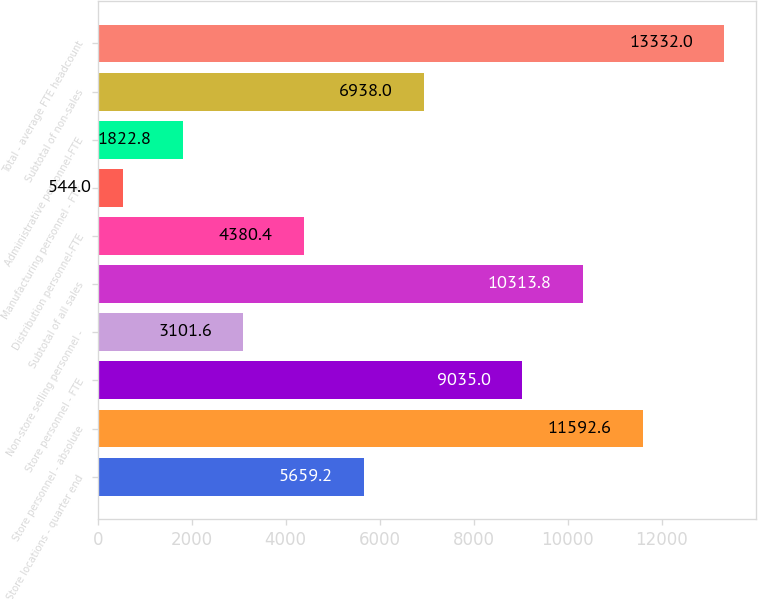<chart> <loc_0><loc_0><loc_500><loc_500><bar_chart><fcel>Store locations - quarter end<fcel>Store personnel - absolute<fcel>Store personnel - FTE<fcel>Non-store selling personnel -<fcel>Subtotal of all sales<fcel>Distribution personnel-FTE<fcel>Manufacturing personnel - FTE<fcel>Administrative personnel-FTE<fcel>Subtotal of non-sales<fcel>Total - average FTE headcount<nl><fcel>5659.2<fcel>11592.6<fcel>9035<fcel>3101.6<fcel>10313.8<fcel>4380.4<fcel>544<fcel>1822.8<fcel>6938<fcel>13332<nl></chart> 